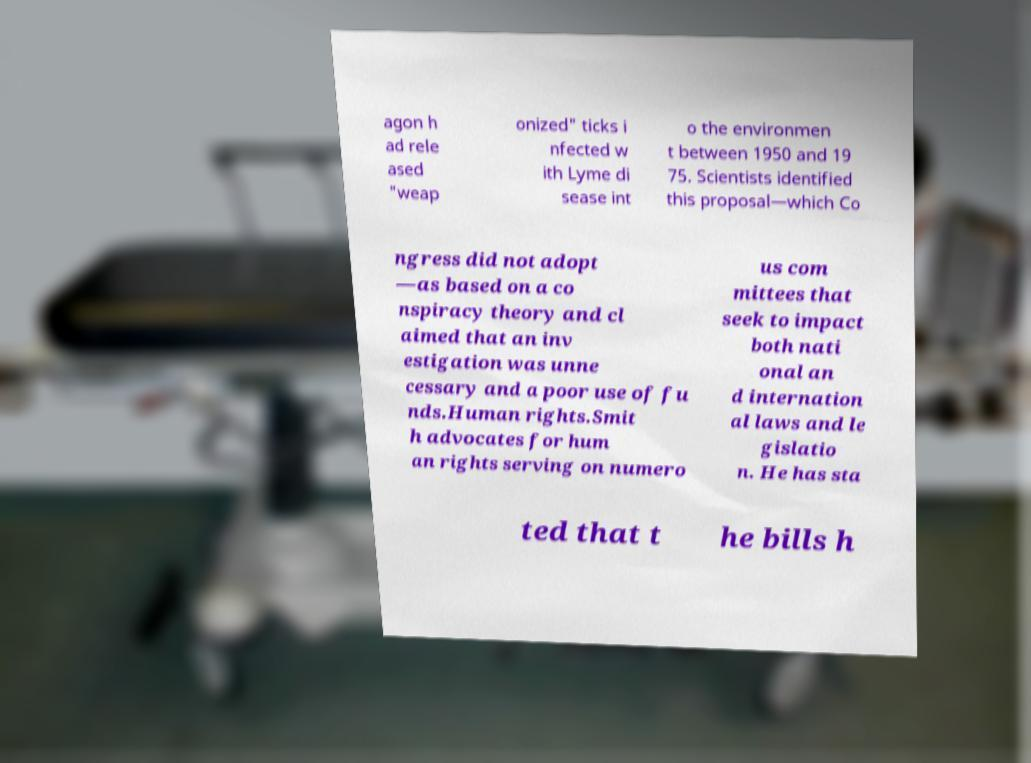Please read and relay the text visible in this image. What does it say? agon h ad rele ased "weap onized" ticks i nfected w ith Lyme di sease int o the environmen t between 1950 and 19 75. Scientists identified this proposal—which Co ngress did not adopt —as based on a co nspiracy theory and cl aimed that an inv estigation was unne cessary and a poor use of fu nds.Human rights.Smit h advocates for hum an rights serving on numero us com mittees that seek to impact both nati onal an d internation al laws and le gislatio n. He has sta ted that t he bills h 